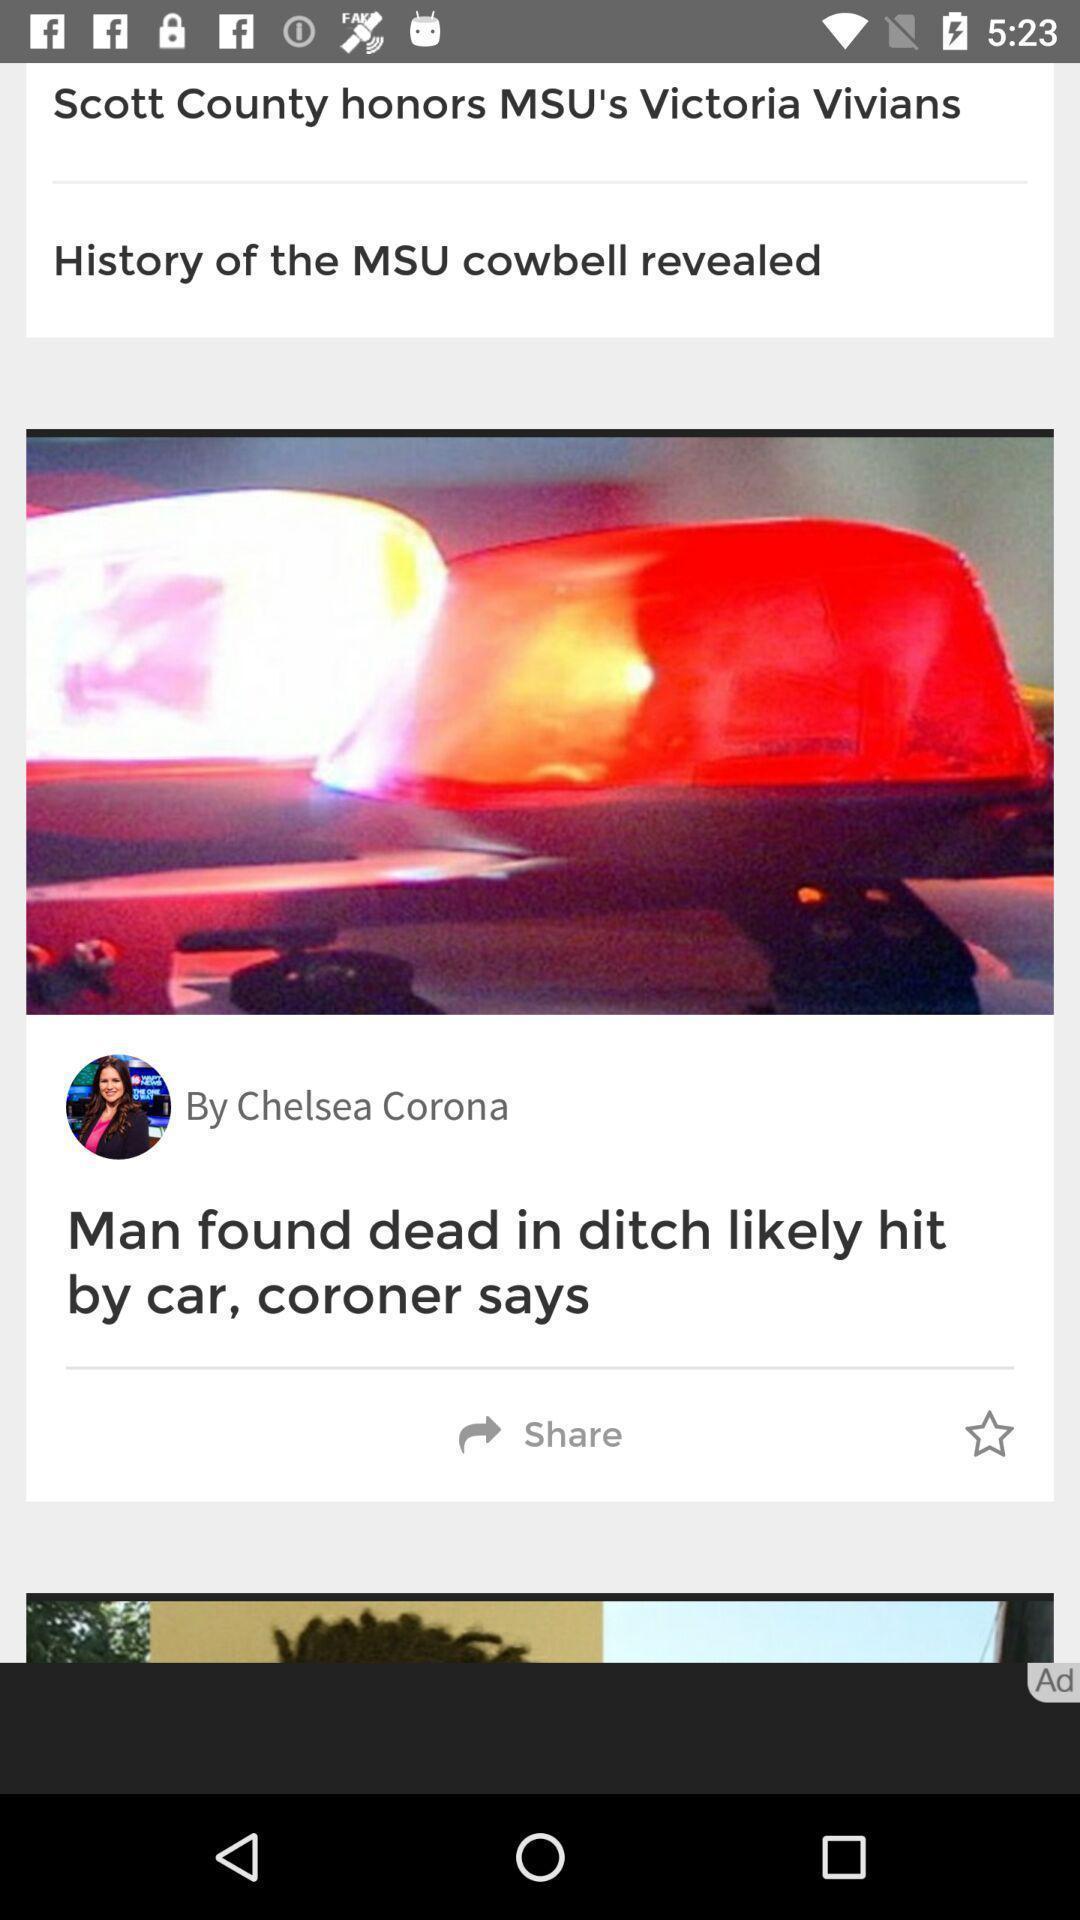Explain the elements present in this screenshot. Screen page of a news app. 